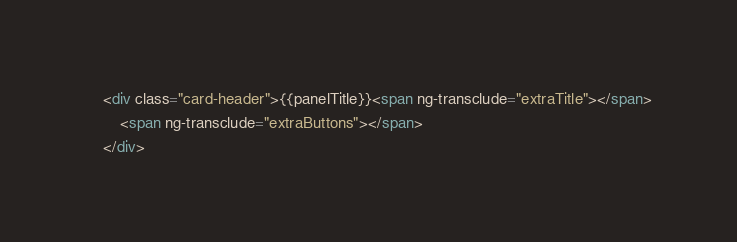Convert code to text. <code><loc_0><loc_0><loc_500><loc_500><_HTML_>    <div class="card-header">{{panelTitle}}<span ng-transclude="extraTitle"></span>
        <span ng-transclude="extraButtons"></span>
    </div></code> 